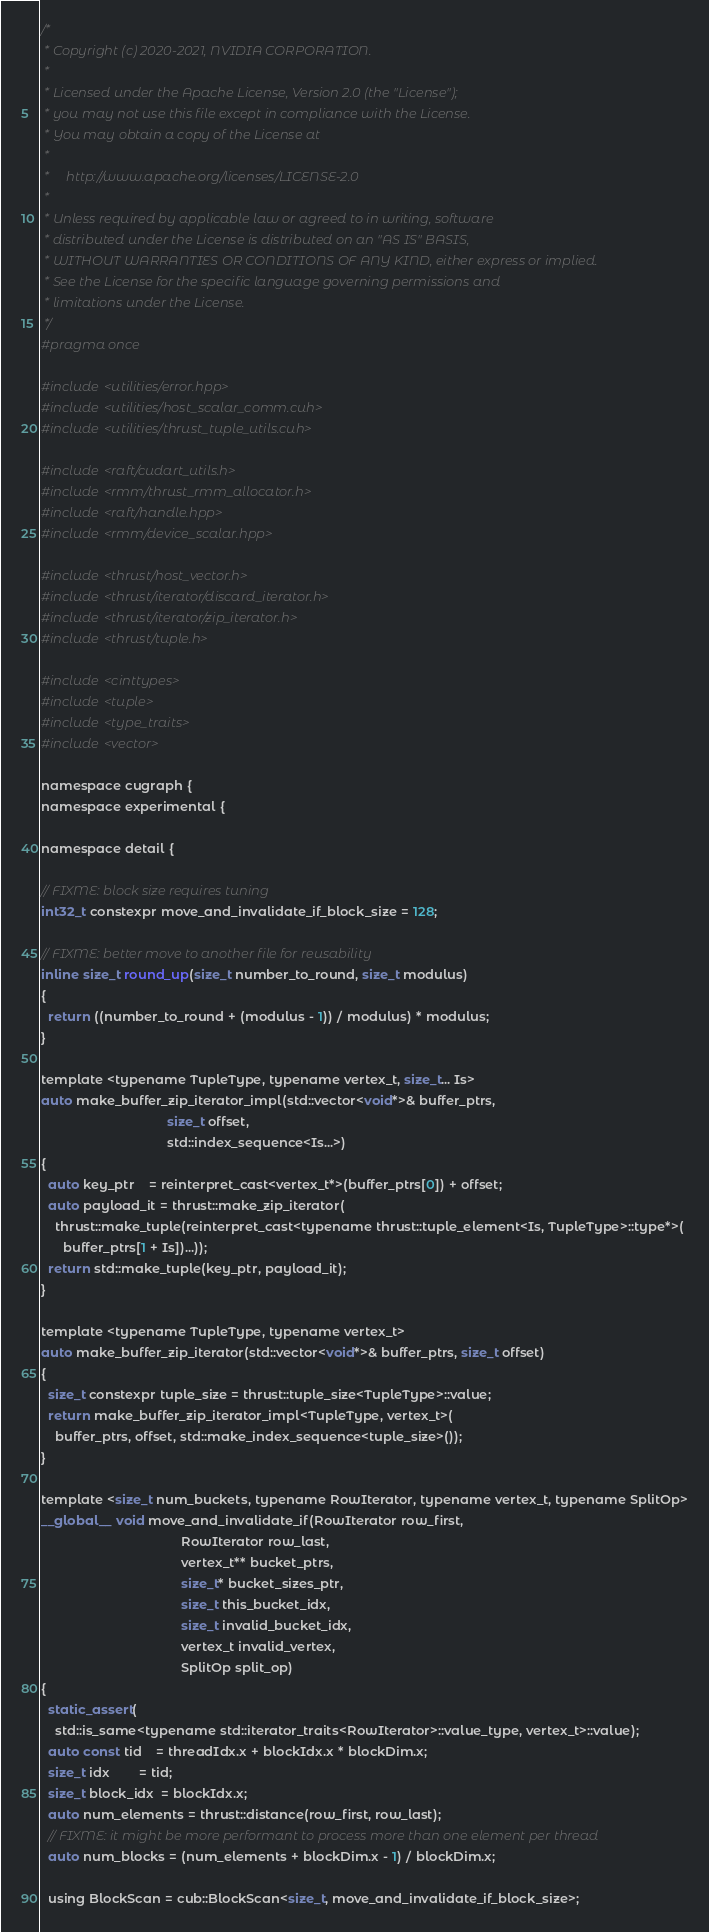Convert code to text. <code><loc_0><loc_0><loc_500><loc_500><_Cuda_>/*
 * Copyright (c) 2020-2021, NVIDIA CORPORATION.
 *
 * Licensed under the Apache License, Version 2.0 (the "License");
 * you may not use this file except in compliance with the License.
 * You may obtain a copy of the License at
 *
 *     http://www.apache.org/licenses/LICENSE-2.0
 *
 * Unless required by applicable law or agreed to in writing, software
 * distributed under the License is distributed on an "AS IS" BASIS,
 * WITHOUT WARRANTIES OR CONDITIONS OF ANY KIND, either express or implied.
 * See the License for the specific language governing permissions and
 * limitations under the License.
 */
#pragma once

#include <utilities/error.hpp>
#include <utilities/host_scalar_comm.cuh>
#include <utilities/thrust_tuple_utils.cuh>

#include <raft/cudart_utils.h>
#include <rmm/thrust_rmm_allocator.h>
#include <raft/handle.hpp>
#include <rmm/device_scalar.hpp>

#include <thrust/host_vector.h>
#include <thrust/iterator/discard_iterator.h>
#include <thrust/iterator/zip_iterator.h>
#include <thrust/tuple.h>

#include <cinttypes>
#include <tuple>
#include <type_traits>
#include <vector>

namespace cugraph {
namespace experimental {

namespace detail {

// FIXME: block size requires tuning
int32_t constexpr move_and_invalidate_if_block_size = 128;

// FIXME: better move to another file for reusability
inline size_t round_up(size_t number_to_round, size_t modulus)
{
  return ((number_to_round + (modulus - 1)) / modulus) * modulus;
}

template <typename TupleType, typename vertex_t, size_t... Is>
auto make_buffer_zip_iterator_impl(std::vector<void*>& buffer_ptrs,
                                   size_t offset,
                                   std::index_sequence<Is...>)
{
  auto key_ptr    = reinterpret_cast<vertex_t*>(buffer_ptrs[0]) + offset;
  auto payload_it = thrust::make_zip_iterator(
    thrust::make_tuple(reinterpret_cast<typename thrust::tuple_element<Is, TupleType>::type*>(
      buffer_ptrs[1 + Is])...));
  return std::make_tuple(key_ptr, payload_it);
}

template <typename TupleType, typename vertex_t>
auto make_buffer_zip_iterator(std::vector<void*>& buffer_ptrs, size_t offset)
{
  size_t constexpr tuple_size = thrust::tuple_size<TupleType>::value;
  return make_buffer_zip_iterator_impl<TupleType, vertex_t>(
    buffer_ptrs, offset, std::make_index_sequence<tuple_size>());
}

template <size_t num_buckets, typename RowIterator, typename vertex_t, typename SplitOp>
__global__ void move_and_invalidate_if(RowIterator row_first,
                                       RowIterator row_last,
                                       vertex_t** bucket_ptrs,
                                       size_t* bucket_sizes_ptr,
                                       size_t this_bucket_idx,
                                       size_t invalid_bucket_idx,
                                       vertex_t invalid_vertex,
                                       SplitOp split_op)
{
  static_assert(
    std::is_same<typename std::iterator_traits<RowIterator>::value_type, vertex_t>::value);
  auto const tid    = threadIdx.x + blockIdx.x * blockDim.x;
  size_t idx        = tid;
  size_t block_idx  = blockIdx.x;
  auto num_elements = thrust::distance(row_first, row_last);
  // FIXME: it might be more performant to process more than one element per thread
  auto num_blocks = (num_elements + blockDim.x - 1) / blockDim.x;

  using BlockScan = cub::BlockScan<size_t, move_and_invalidate_if_block_size>;</code> 